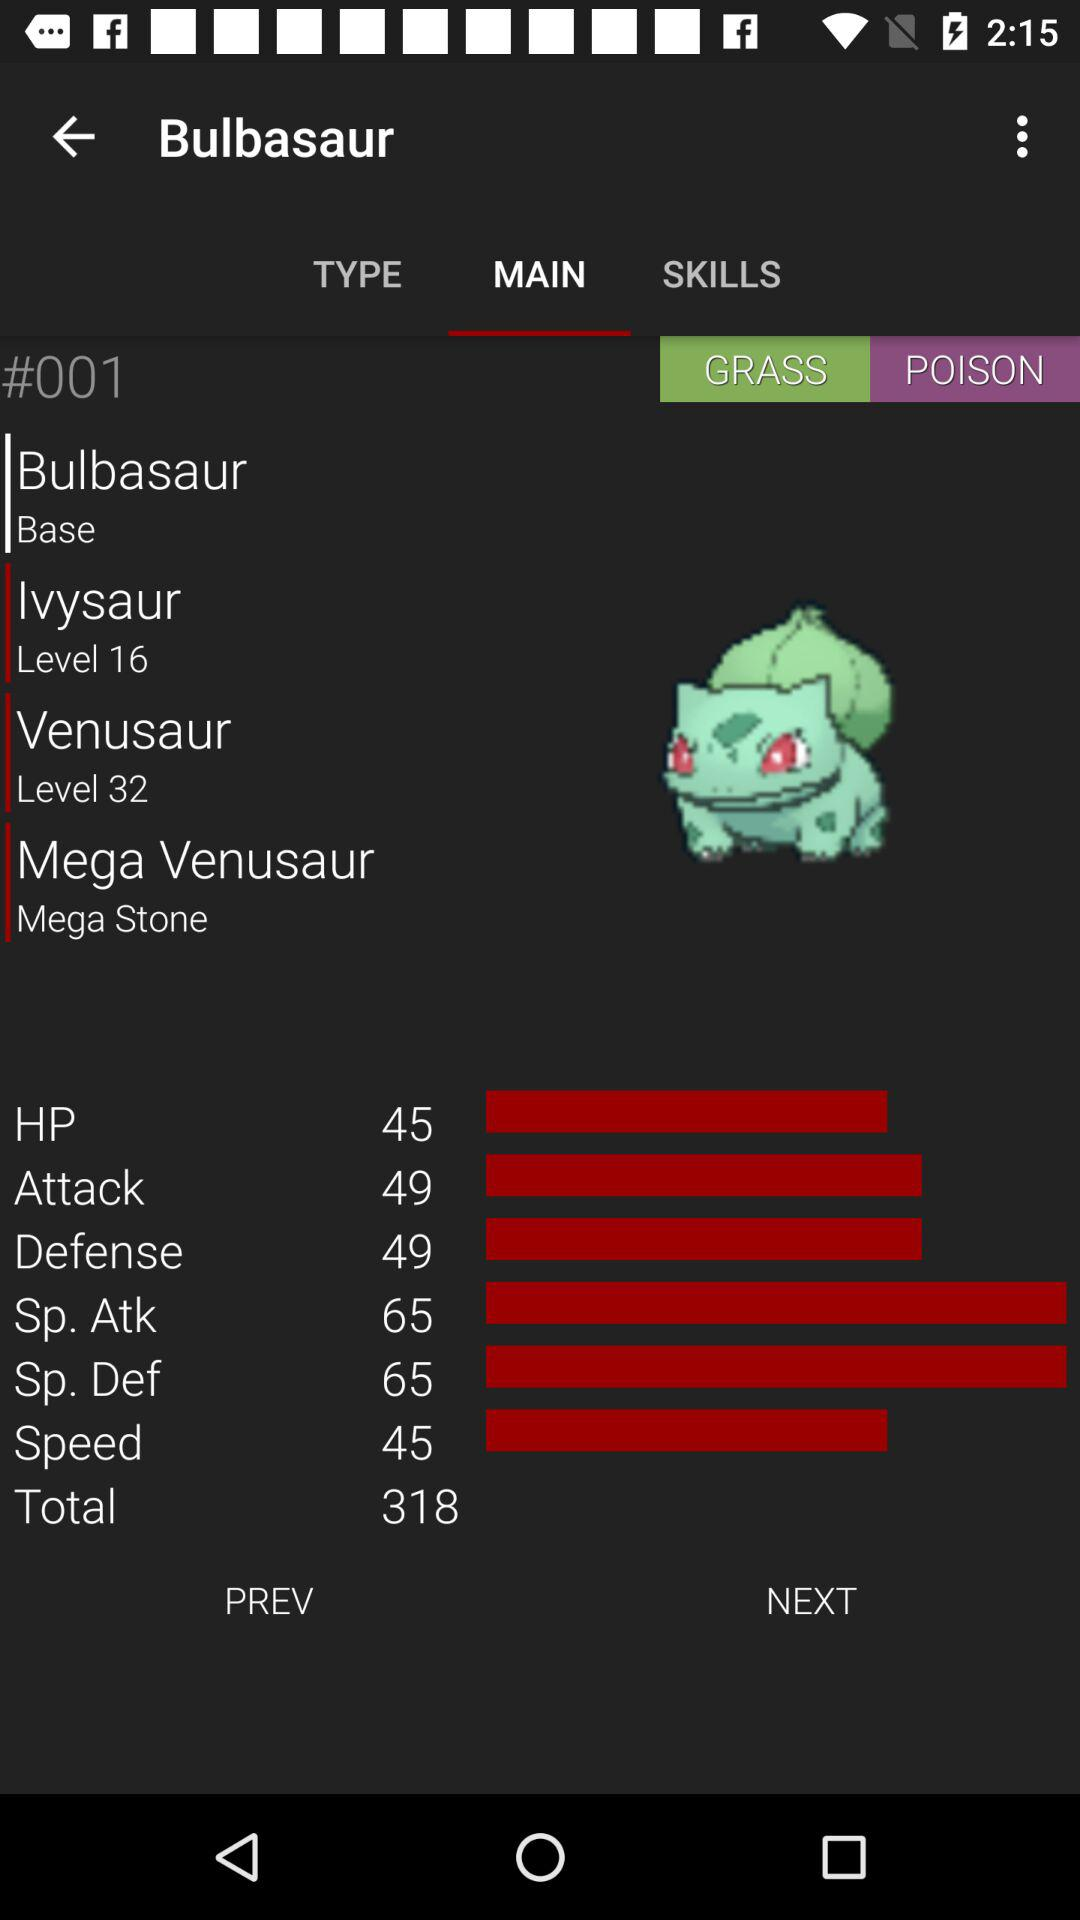What is the level of Ivysaur? The level of Ivysaur is 16. 